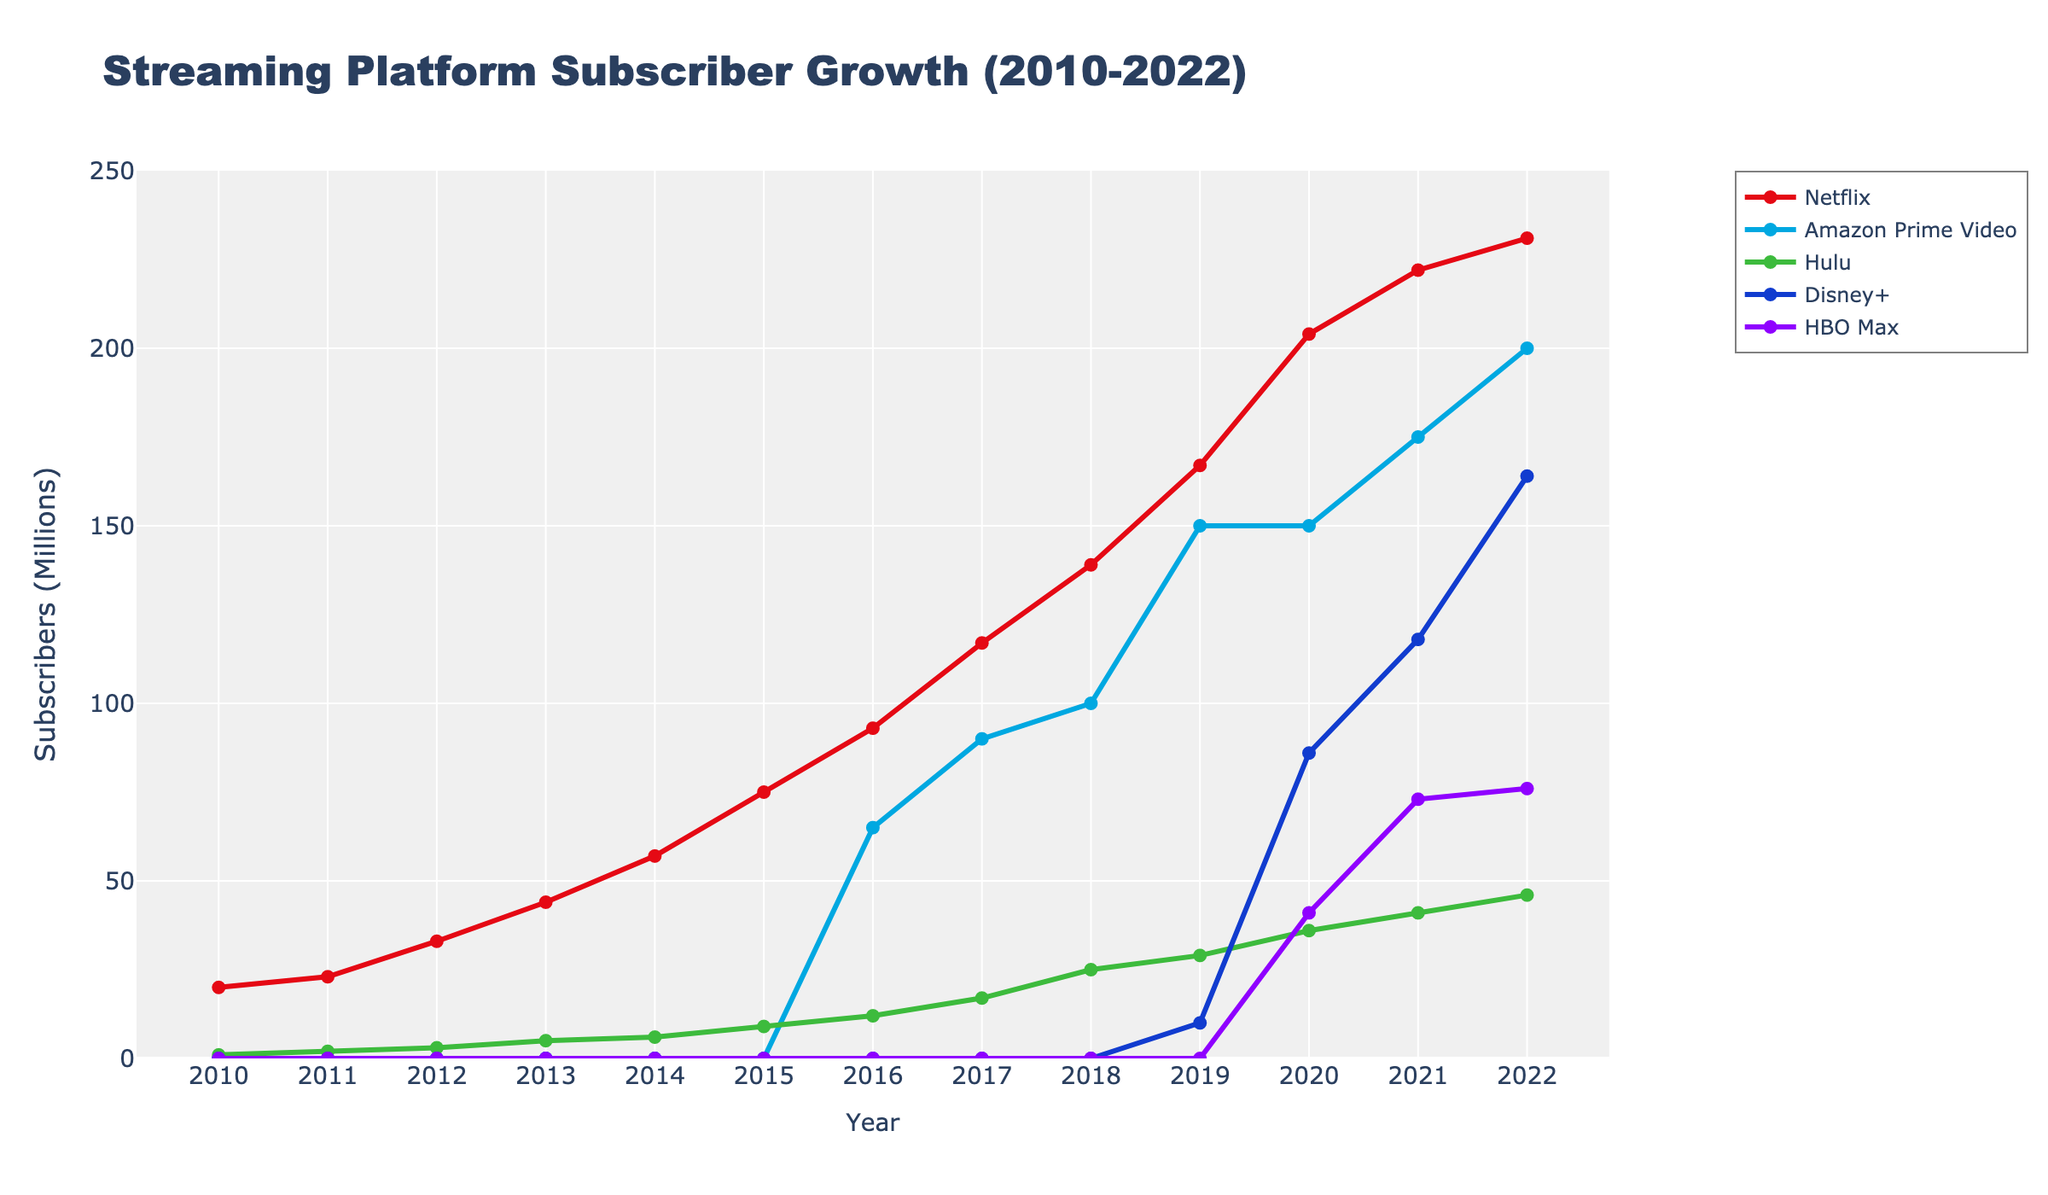What year did Netflix reach 100 million subscribers? Look at the line representing Netflix and find the year when it intersects the 100 million subscribers mark.
Answer: 2017 Which platform had the highest subscriber growth between 2019 and 2021? Compare the differences in subscribers for each platform between 2019 and 2021. Netflix grew from 167 to 222 (+55), Amazon Prime Video from 150 to 175 (+25), Hulu from 29 to 41 (+12), Disney+ from 10 to 118 (+108), and HBO Max from 0 to 73 (+73).
Answer: Disney+ In which year did Disney+ overtake Hulu in subscriber numbers? Check the lines for Disney+ and Hulu. Find the year when the Disney+ line surpasses the Hulu line, which should be around 2020.
Answer: 2021 How many millions of subscribers did Netflix gain from 2010 to 2020? Subtract Netflix's subscribers in 2010 from those in 2020 (204 - 20).
Answer: 184 Which platform had the least growth between 2010 and 2012? Examine each platform's line and find the differences in subscribers for these years. Only Netflix and Hulu had subscribers during this period. Netflix grew from 20 to 33 (+13), and Hulu grew from 1 to 3 (+2).
Answer: Hulu What is the total number of subscribers for all platforms combined in 2022? Sum up the subscribers for all platforms in 2022. (231 + 200 + 46 + 164 + 76).
Answer: 717 In which year did HBO Max have the largest increase in subscribers? Check the year-to-year increments for HBO Max. The largest increase is between 2020 and 2021, from 41 to 73, a gain of 32 million.
Answer: 2021 Which streaming platform had the slowest initial growth up to its first 10 million subscribers? Consider the years taken for each platform to reach 10 million subscribers. Netflix in 2010, Amazon Prime Video in 2017, Hulu in 2015, Disney+ in 2019, HBO Max in 2020. Hulu took the longest time, reaching 10 million in 2015.
Answer: Hulu How many platforms surpassed 100 million subscribers by 2022? Check each platform's subscribers for the year 2022: Netflix (231), Amazon Prime Video (200), Hulu (46), Disney+ (164), HBO Max (76). Count how many surpass 100 million.
Answer: 3 